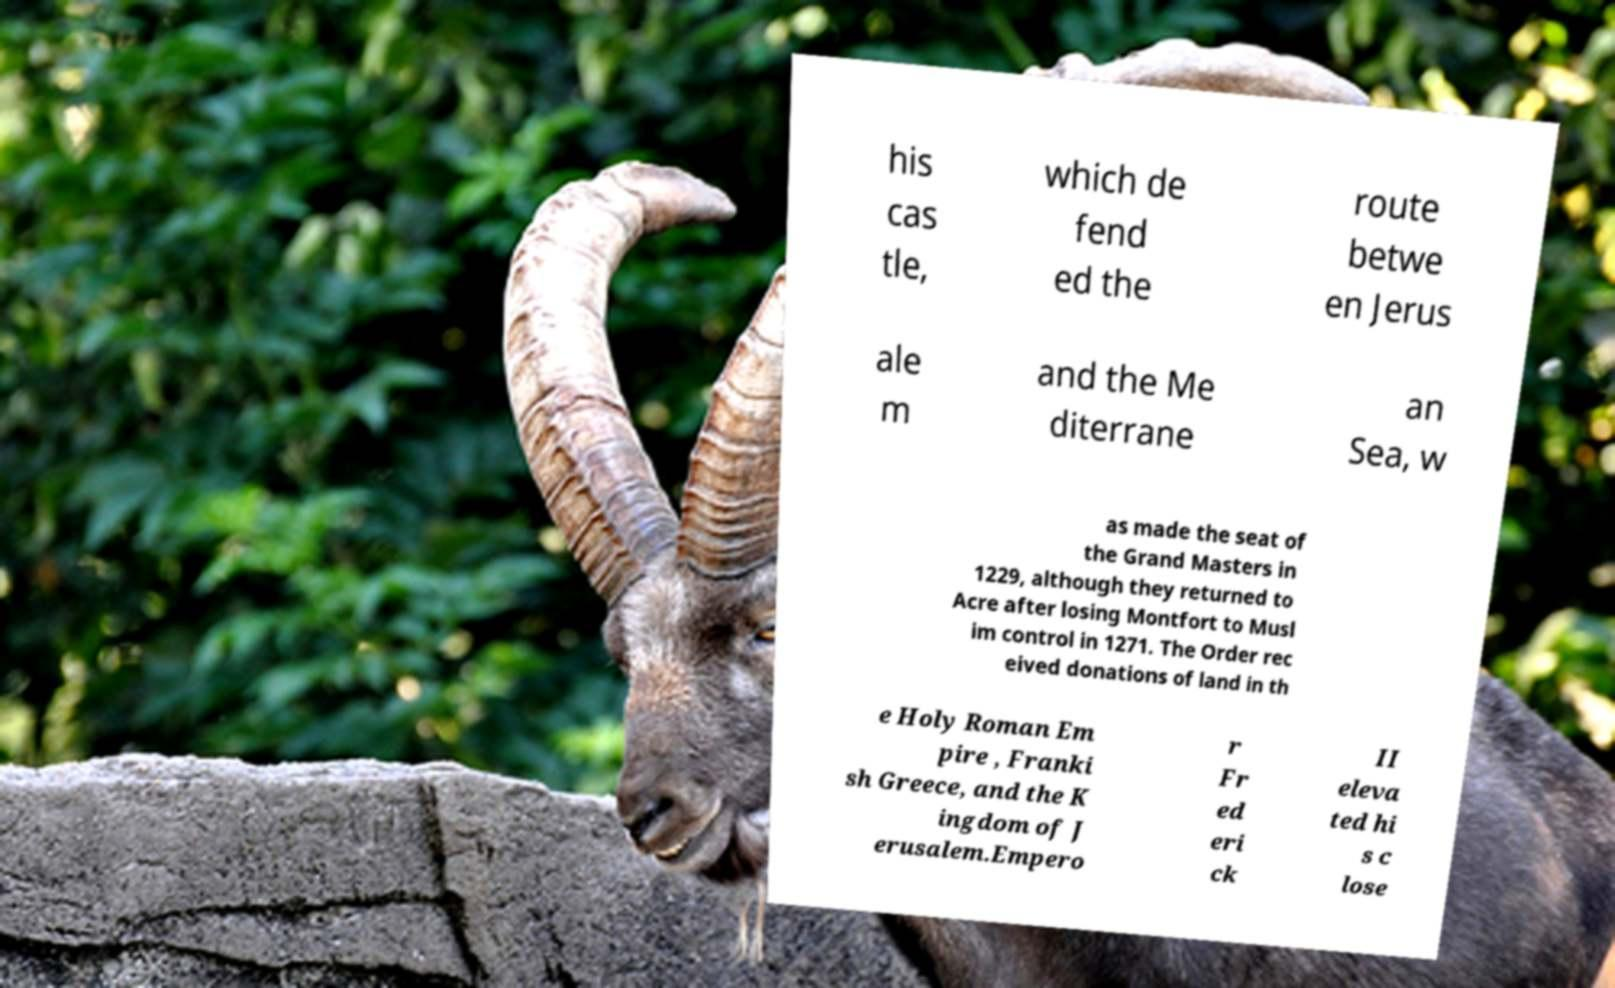Please read and relay the text visible in this image. What does it say? his cas tle, which de fend ed the route betwe en Jerus ale m and the Me diterrane an Sea, w as made the seat of the Grand Masters in 1229, although they returned to Acre after losing Montfort to Musl im control in 1271. The Order rec eived donations of land in th e Holy Roman Em pire , Franki sh Greece, and the K ingdom of J erusalem.Empero r Fr ed eri ck II eleva ted hi s c lose 